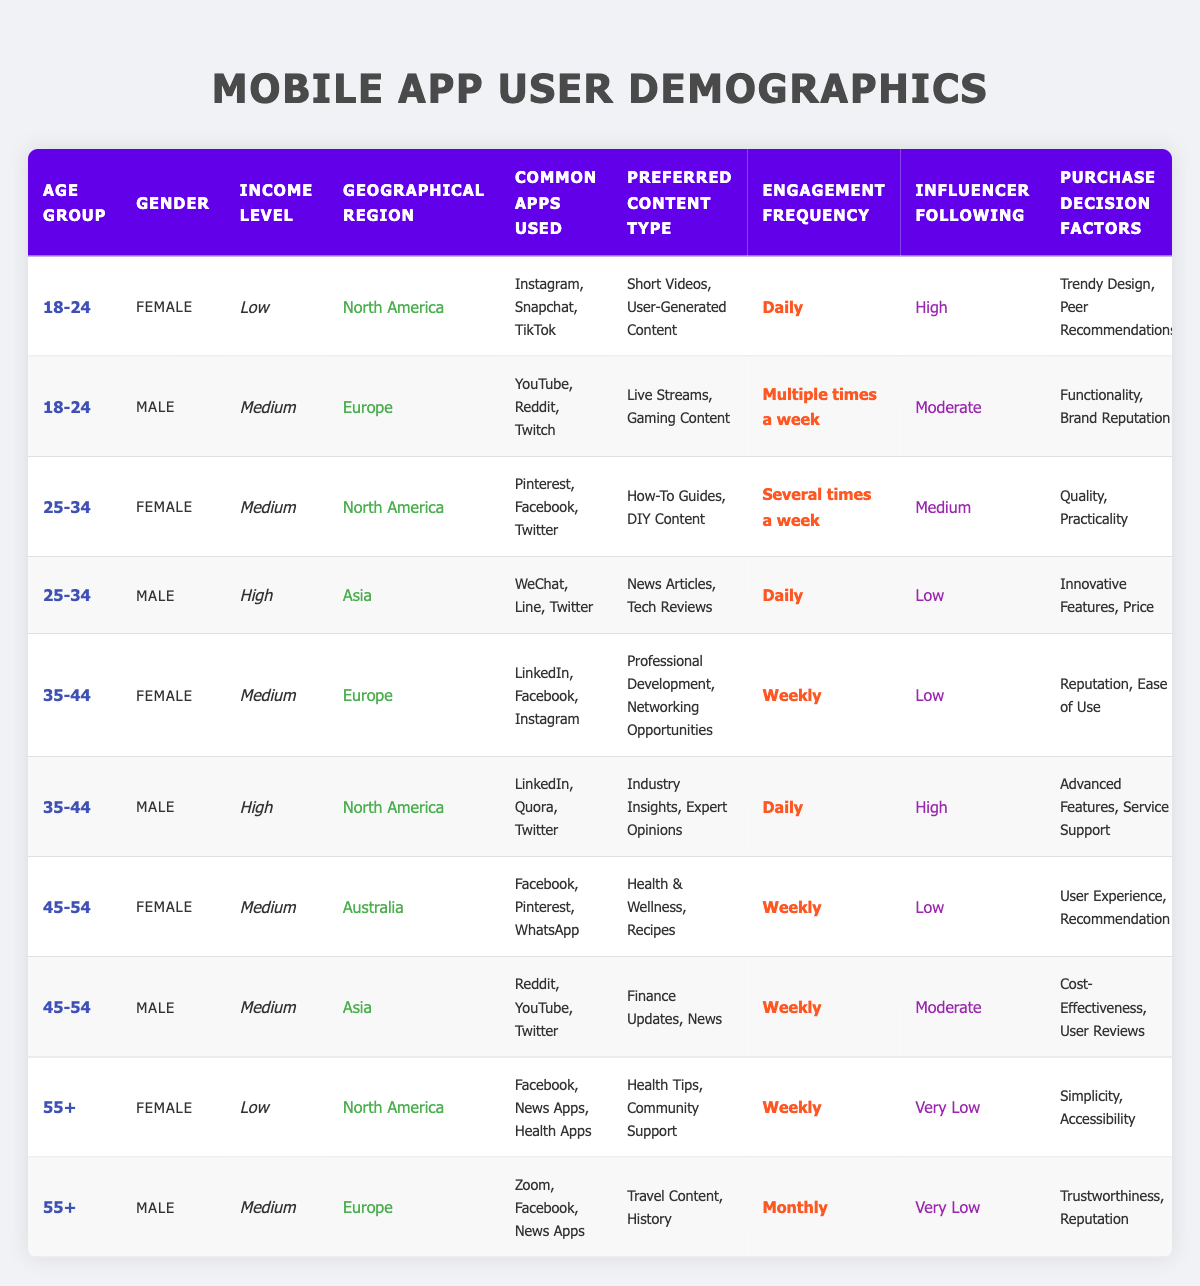What is the most common app used by female users aged 35-44? Referring to the table, the apps used by females in the age group 35-44 are LinkedIn, Facebook, and Instagram. The most commonly listed is Facebook.
Answer: Facebook Which gender has the highest frequency of engagement in the 25-34 age group? In the 25-34 age group, the female is listed as engaging several times a week, while the male is noted for daily engagement. The male therefore has a higher engagement frequency.
Answer: Male How many different preferred content types are listed for users aged 18-24? There are two users in the 18-24 age range, one female prefers Short Videos and User-Generated Content while the male prefers Live Streams and Gaming Content. In total, there are four distinct types listed.
Answer: Four Do users in the 55+ age group have high influencer following? Both females and males in the 55+ age group have a very low influencer following according to the data.
Answer: No What is the average income level of male users across all age groups? Analyzing the data, male users fall into Low (1), Medium (3), and High (2) income levels across six data points. Thus, the average is calculated as (1 + 2 + 2 + 1 + 2 + 3) / 6 = 11 / 6 = 1.83, which is approximately Medium.
Answer: Medium Which geographical region has the highest variety of preferred content types? By checking the regions, North America has users who prefer Short Videos, User-Generated Content, How-To Guides, and DIY Content, totaling four different types. Other regions have fewer types.
Answer: North America What factors do users aged 45-54 prefer when making purchase decisions? Analyzing the table, users aged 45-54 (both male and female) prefer factors such as User Experience and Recommendation (female), and Cost-Effectiveness and User Reviews (male).
Answer: User Experience, Recommendation, Cost-Effectiveness, User Reviews Among the Asian users, who has the highest engagement frequency? The table indicates that the only Asian users are in the 25-34 age group (male) with daily engagement and one female in the 35-44 group who has weekly engagement. Thus, the male has the highest.
Answer: Male Is there a user demographic that engages daily with the content? Yes, both male users in the 18-24 and 25-34 age groups engage daily according to the table.
Answer: Yes How many users listed have a medium income level? Counting from the table, there are four users with a medium income level. They can be found within the 18-24, 25-34, 35-44, and 45-54 age groups.
Answer: Four 